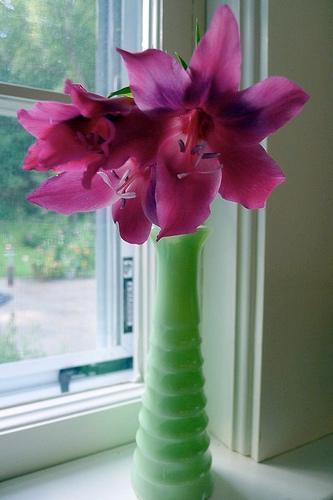How many windows are there?
Give a very brief answer. 1. 